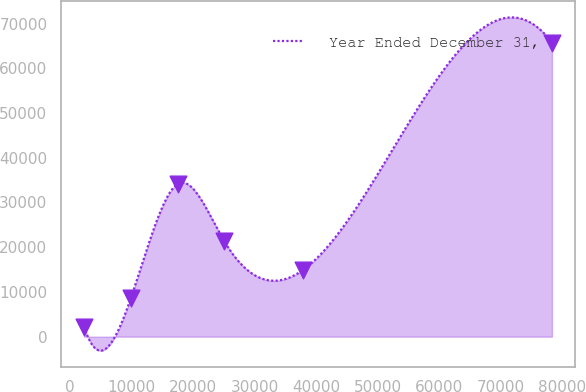<chart> <loc_0><loc_0><loc_500><loc_500><line_chart><ecel><fcel>Year Ended December 31,<nl><fcel>2234.89<fcel>2237.72<nl><fcel>9846.77<fcel>8589.39<nl><fcel>17458.7<fcel>34134.6<nl><fcel>25070.5<fcel>21292.7<nl><fcel>37887.7<fcel>14941.1<nl><fcel>78353.7<fcel>65754.4<nl></chart> 